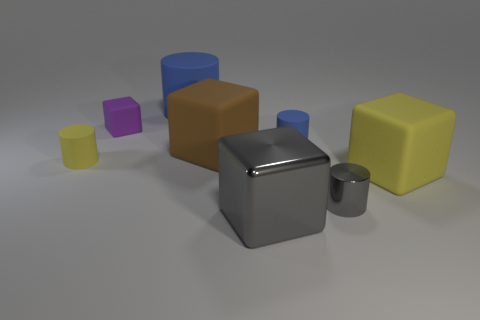Subtract 1 blocks. How many blocks are left? 3 Subtract all purple cylinders. Subtract all green cubes. How many cylinders are left? 4 Add 1 purple objects. How many objects exist? 9 Add 1 blue matte objects. How many blue matte objects exist? 3 Subtract 0 red balls. How many objects are left? 8 Subtract all tiny cylinders. Subtract all purple matte objects. How many objects are left? 4 Add 8 small yellow matte cylinders. How many small yellow matte cylinders are left? 9 